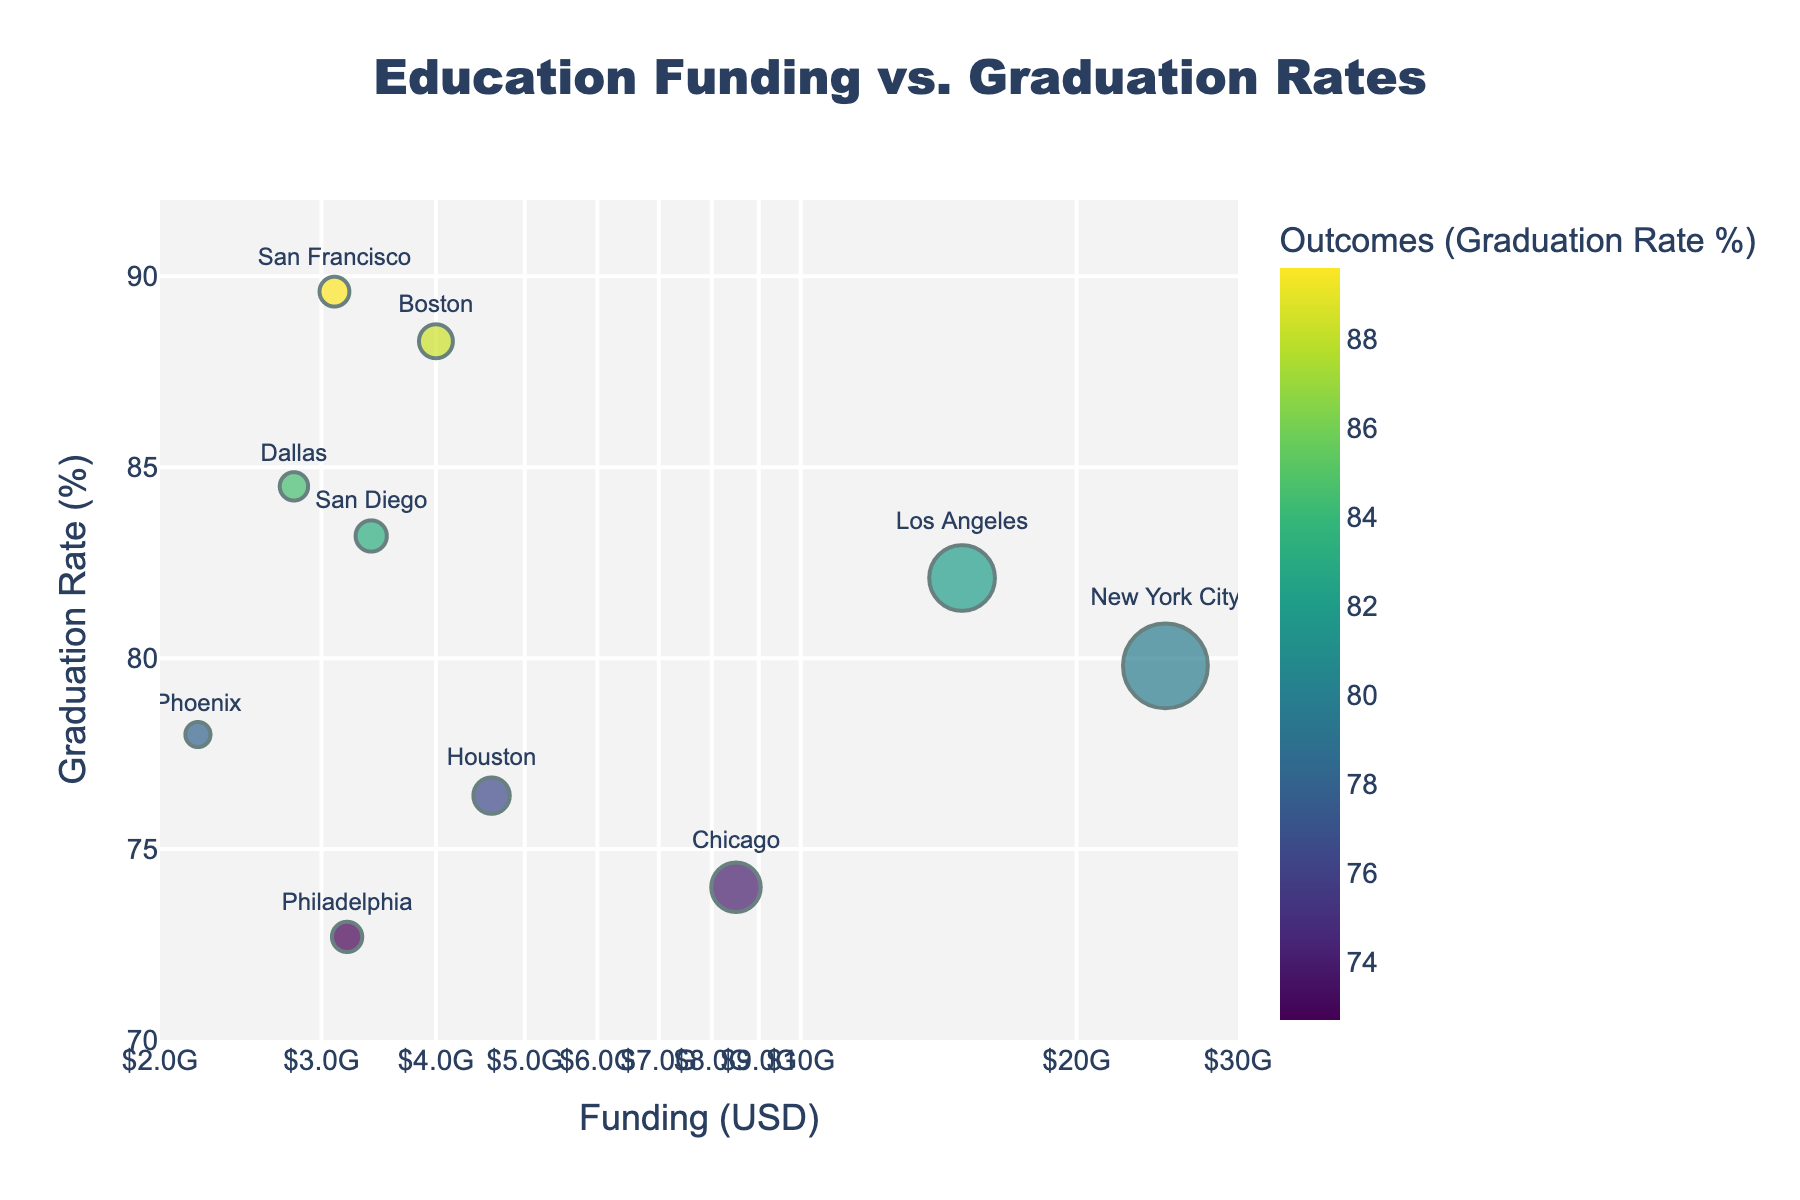What is the title of the scatter plot? The title is located at the top of the scatter plot. It is typically a clear and concise description of the plot's content. In this case, it reads "Education Funding vs. Graduation Rates."
Answer: Education Funding vs. Graduation Rates What variable is plotted on the x-axis? The x-axis typically shows one of the variables being compared. Here, it shows "Funding (USD)" as indicated by the label at the bottom of the axis.
Answer: Funding (USD) Which district has the highest graduation rate? Look for the data point with the highest y-axis value. In this scatter plot, "San Francisco" has the highest graduation rate, with a rate of 89.6%.
Answer: San Francisco How does Los Angeles compare to Chicago in terms of funding and outcomes? To compare, note the x and y positions of the points representing Los Angeles and Chicago. Los Angeles has higher funding but a higher graduation rate compared to Chicago. Specifically, Los Angeles has $15 billion in funding and an 82.1% graduation rate, while Chicago has $8.5 billion in funding and a 74.0% graduation rate.
Answer: Los Angeles has higher funding and higher outcomes than Chicago Which districts have funding amounts below $4 billion? Identify the points on the x-axis corresponding to funding less than $4 billion. The districts are Houston, Philadelphia, San Diego, Dallas, San Francisco, Boston, and Phoenix, since they are all located to the left of the $4 billion mark on the log-scale x-axis.
Answer: Houston, Philadelphia, San Diego, Dallas, San Francisco, Boston, Phoenix What is the graduation rate difference between Boston and Houston? Subtract the graduation rate of Houston from Boston’s rate. Boston has an 88.3% rate, and Houston has a 76.4% rate. Thus, 88.3 - 76.4 = 11.9%.
Answer: 11.9% Is there a correlation between the amount of funding and graduation rates across districts? Observe the general trend in the scatter plot. While some districts with higher funding do have higher graduation rates, there are exceptions. For example, New York City has the highest funding but not the highest graduation rate, indicating a complex relationship.
Answer: It's complex Which district has the largest bubble size, and what does it represent? The largest bubble on the scatter plot represents the district with the most funding. New York City's bubble is the largest, representing $25 billion in funding.
Answer: New York City What is the average graduation rate of districts with funding greater than $3 billion? Average the graduation rates of New York City, Los Angeles, Chicago, Houston, San Diego, Dallas, San Francisco, and Boston. Adding rates: 79.8 + 82.1 + 74.0 + 76.4 + 83.2 + 84.5 + 89.6 + 88.3 = 657.9. Dividing by the 8 districts: 657.9 / 8 = 82.24%.
Answer: 82.24% 